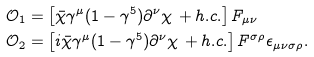Convert formula to latex. <formula><loc_0><loc_0><loc_500><loc_500>\mathcal { O } _ { 1 } & = \left [ \bar { \chi } \gamma ^ { \mu } ( 1 - \gamma ^ { 5 } ) \partial ^ { \nu } \chi \, + h . c . \right ] F _ { \mu \nu } \\ \mathcal { O } _ { 2 } & = \left [ i \bar { \chi } \gamma ^ { \mu } ( 1 - \gamma ^ { 5 } ) \partial ^ { \nu } \chi \, + h . c . \right ] F ^ { \sigma \rho } \epsilon _ { \mu \nu \sigma \rho } .</formula> 